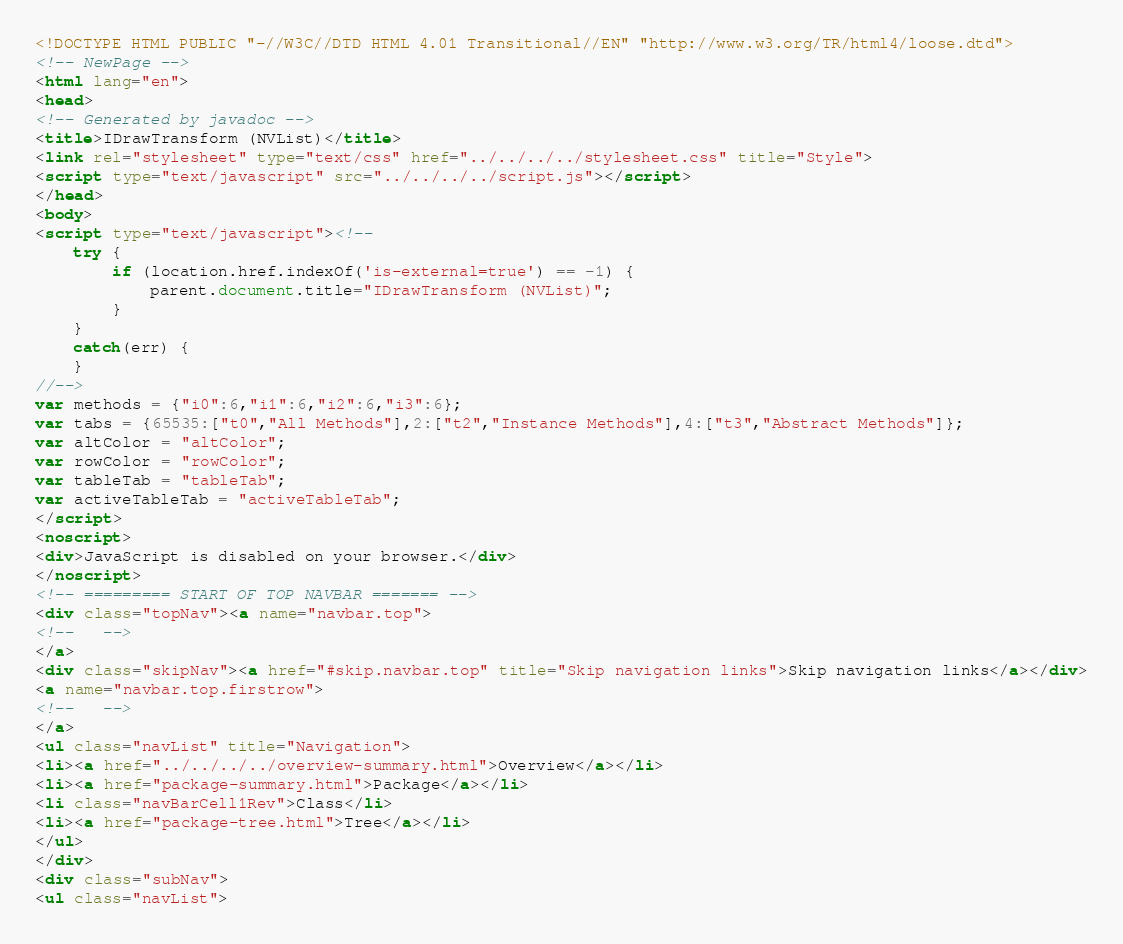<code> <loc_0><loc_0><loc_500><loc_500><_HTML_><!DOCTYPE HTML PUBLIC "-//W3C//DTD HTML 4.01 Transitional//EN" "http://www.w3.org/TR/html4/loose.dtd">
<!-- NewPage -->
<html lang="en">
<head>
<!-- Generated by javadoc -->
<title>IDrawTransform (NVList)</title>
<link rel="stylesheet" type="text/css" href="../../../../stylesheet.css" title="Style">
<script type="text/javascript" src="../../../../script.js"></script>
</head>
<body>
<script type="text/javascript"><!--
    try {
        if (location.href.indexOf('is-external=true') == -1) {
            parent.document.title="IDrawTransform (NVList)";
        }
    }
    catch(err) {
    }
//-->
var methods = {"i0":6,"i1":6,"i2":6,"i3":6};
var tabs = {65535:["t0","All Methods"],2:["t2","Instance Methods"],4:["t3","Abstract Methods"]};
var altColor = "altColor";
var rowColor = "rowColor";
var tableTab = "tableTab";
var activeTableTab = "activeTableTab";
</script>
<noscript>
<div>JavaScript is disabled on your browser.</div>
</noscript>
<!-- ========= START OF TOP NAVBAR ======= -->
<div class="topNav"><a name="navbar.top">
<!--   -->
</a>
<div class="skipNav"><a href="#skip.navbar.top" title="Skip navigation links">Skip navigation links</a></div>
<a name="navbar.top.firstrow">
<!--   -->
</a>
<ul class="navList" title="Navigation">
<li><a href="../../../../overview-summary.html">Overview</a></li>
<li><a href="package-summary.html">Package</a></li>
<li class="navBarCell1Rev">Class</li>
<li><a href="package-tree.html">Tree</a></li>
</ul>
</div>
<div class="subNav">
<ul class="navList"></code> 